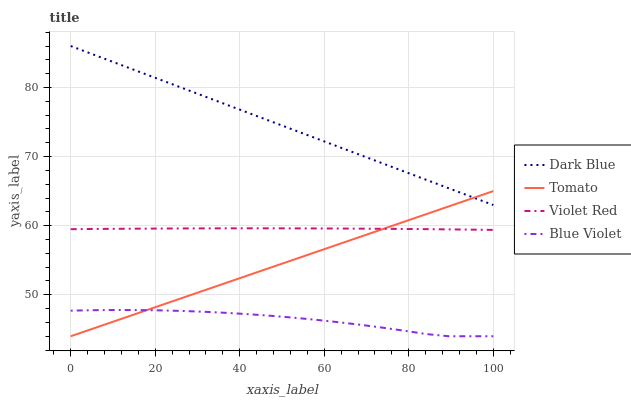Does Blue Violet have the minimum area under the curve?
Answer yes or no. Yes. Does Dark Blue have the maximum area under the curve?
Answer yes or no. Yes. Does Violet Red have the minimum area under the curve?
Answer yes or no. No. Does Violet Red have the maximum area under the curve?
Answer yes or no. No. Is Tomato the smoothest?
Answer yes or no. Yes. Is Blue Violet the roughest?
Answer yes or no. Yes. Is Dark Blue the smoothest?
Answer yes or no. No. Is Dark Blue the roughest?
Answer yes or no. No. Does Violet Red have the lowest value?
Answer yes or no. No. Does Dark Blue have the highest value?
Answer yes or no. Yes. Does Violet Red have the highest value?
Answer yes or no. No. Is Blue Violet less than Violet Red?
Answer yes or no. Yes. Is Dark Blue greater than Violet Red?
Answer yes or no. Yes. Does Tomato intersect Blue Violet?
Answer yes or no. Yes. Is Tomato less than Blue Violet?
Answer yes or no. No. Is Tomato greater than Blue Violet?
Answer yes or no. No. Does Blue Violet intersect Violet Red?
Answer yes or no. No. 